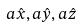Convert formula to latex. <formula><loc_0><loc_0><loc_500><loc_500>a \hat { x } , a \hat { y } , a \hat { z }</formula> 